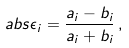Convert formula to latex. <formula><loc_0><loc_0><loc_500><loc_500>\ a b s { \epsilon _ { i } } = \frac { a _ { i } - b _ { i } } { a _ { i } + b _ { i } } \, ,</formula> 